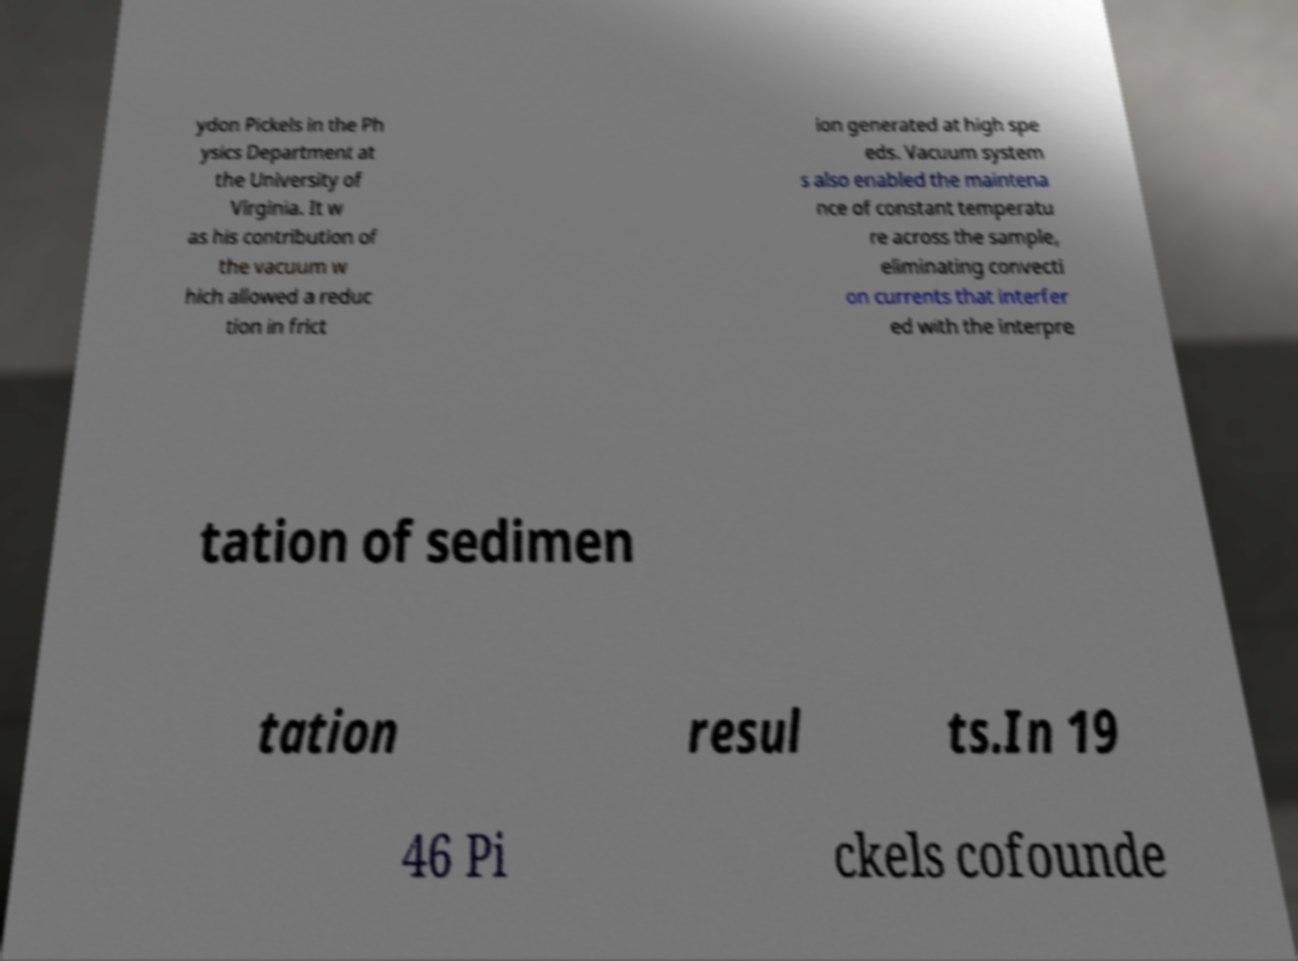Can you read and provide the text displayed in the image?This photo seems to have some interesting text. Can you extract and type it out for me? ydon Pickels in the Ph ysics Department at the University of Virginia. It w as his contribution of the vacuum w hich allowed a reduc tion in frict ion generated at high spe eds. Vacuum system s also enabled the maintena nce of constant temperatu re across the sample, eliminating convecti on currents that interfer ed with the interpre tation of sedimen tation resul ts.In 19 46 Pi ckels cofounde 